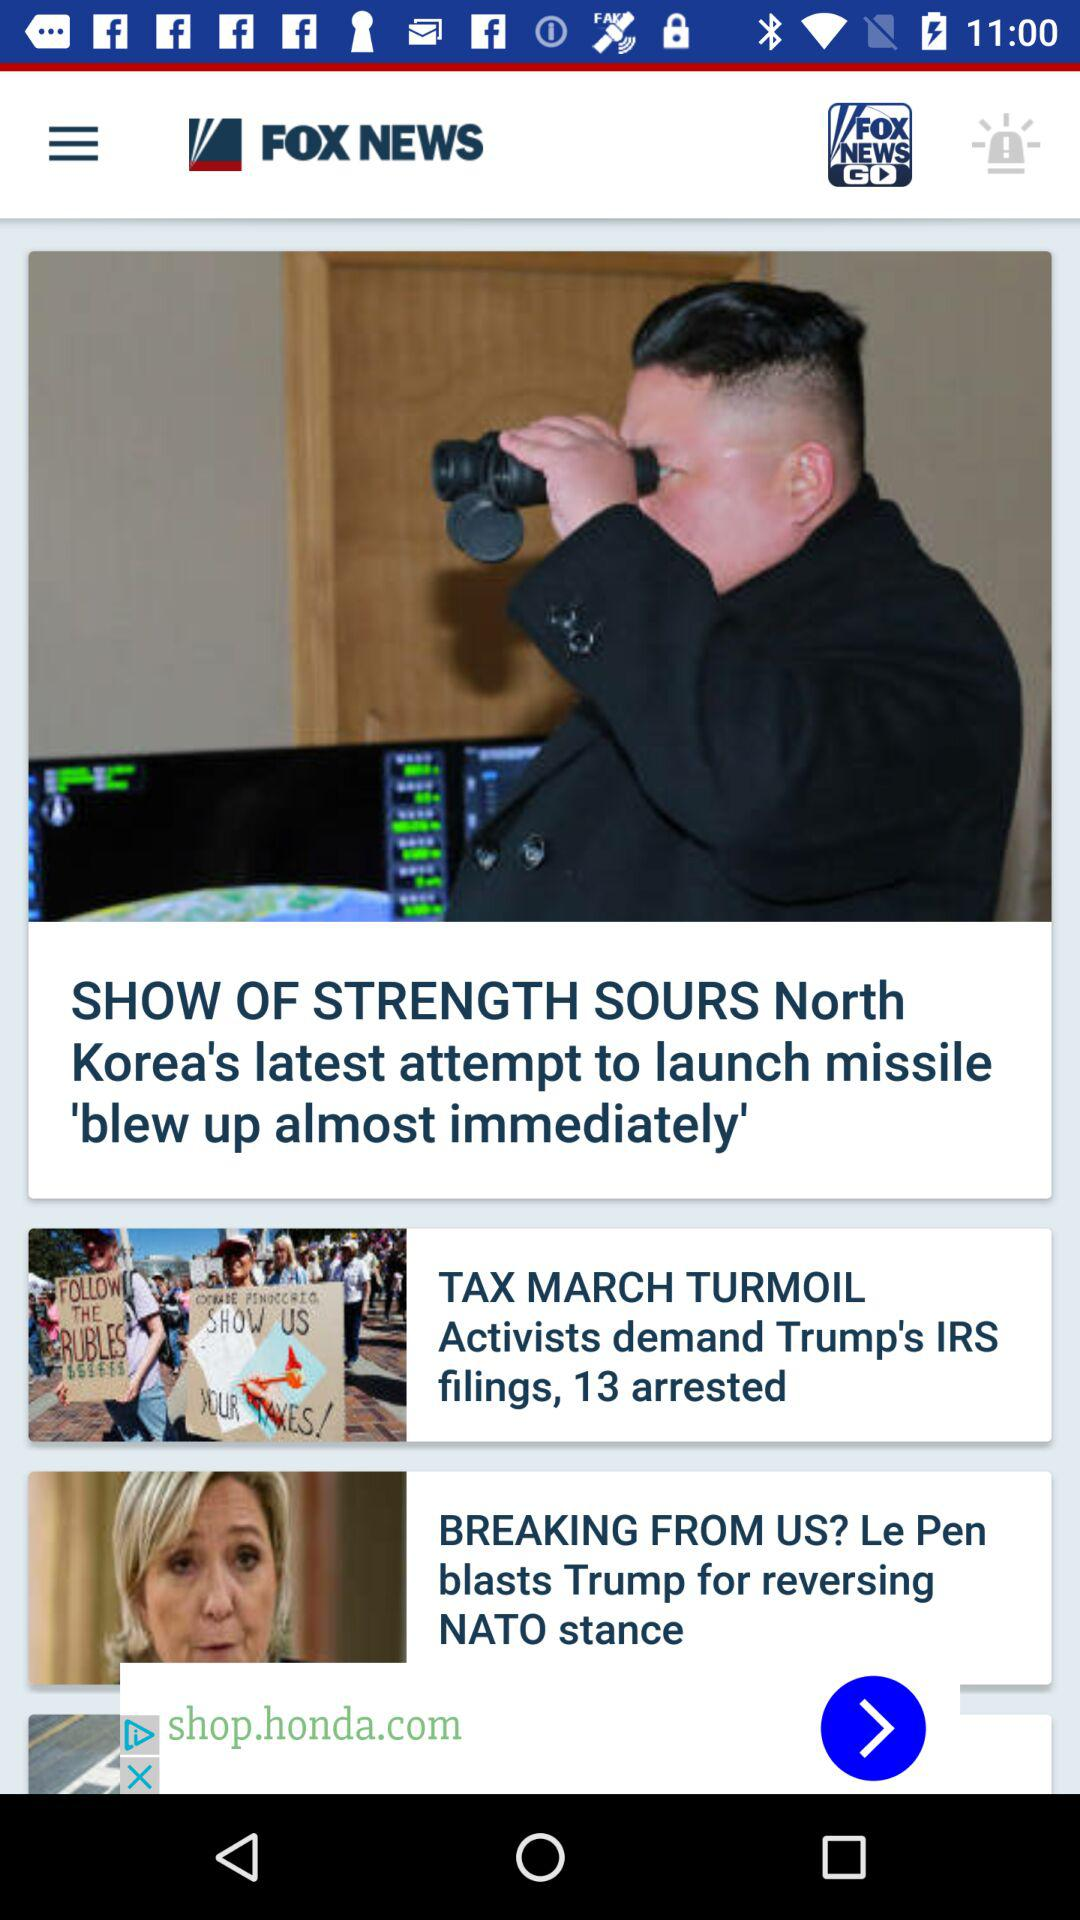How many more news items are there after the first item?
Answer the question using a single word or phrase. 2 